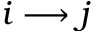Convert formula to latex. <formula><loc_0><loc_0><loc_500><loc_500>i \longrightarrow j</formula> 